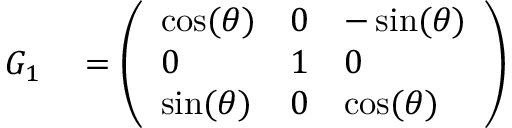<formula> <loc_0><loc_0><loc_500><loc_500>\begin{array} { r l } { G _ { 1 } } & = { \left ( \begin{array} { l l l } { \cos ( \theta ) } & { 0 } & { - \sin ( \theta ) } \\ { 0 } & { 1 } & { 0 } \\ { \sin ( \theta ) } & { 0 } & { \cos ( \theta ) } \end{array} \right ) } } \end{array}</formula> 